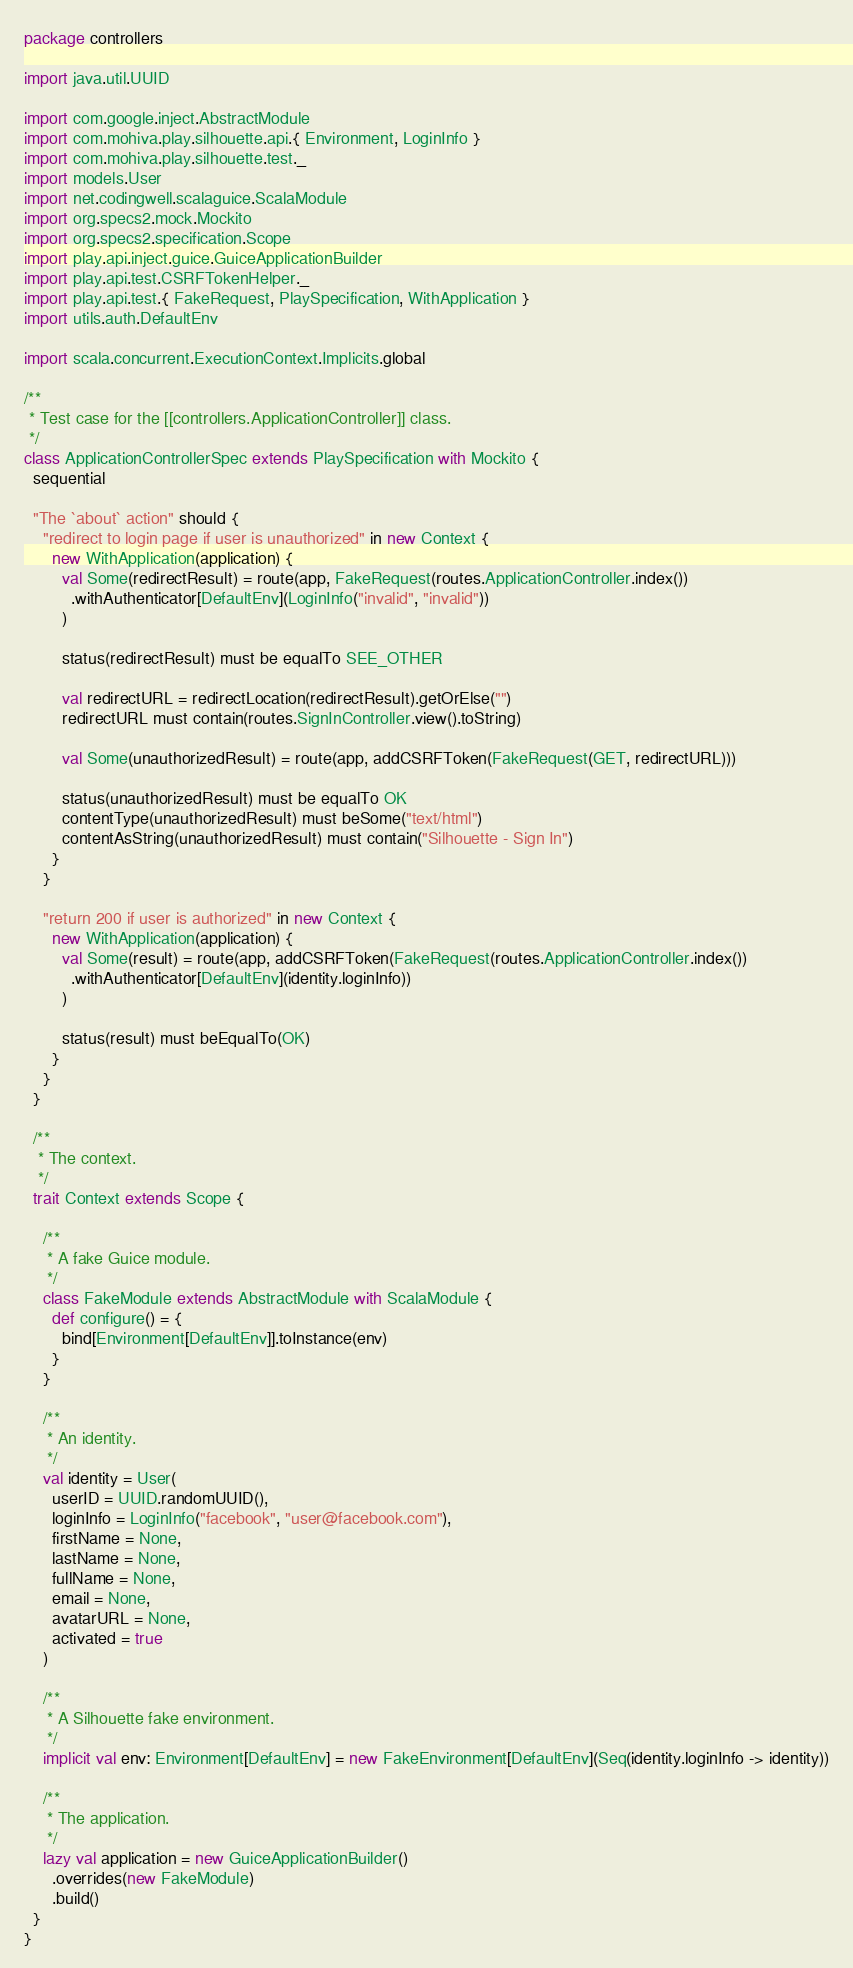<code> <loc_0><loc_0><loc_500><loc_500><_Scala_>package controllers

import java.util.UUID

import com.google.inject.AbstractModule
import com.mohiva.play.silhouette.api.{ Environment, LoginInfo }
import com.mohiva.play.silhouette.test._
import models.User
import net.codingwell.scalaguice.ScalaModule
import org.specs2.mock.Mockito
import org.specs2.specification.Scope
import play.api.inject.guice.GuiceApplicationBuilder
import play.api.test.CSRFTokenHelper._
import play.api.test.{ FakeRequest, PlaySpecification, WithApplication }
import utils.auth.DefaultEnv

import scala.concurrent.ExecutionContext.Implicits.global

/**
 * Test case for the [[controllers.ApplicationController]] class.
 */
class ApplicationControllerSpec extends PlaySpecification with Mockito {
  sequential

  "The `about` action" should {
    "redirect to login page if user is unauthorized" in new Context {
      new WithApplication(application) {
        val Some(redirectResult) = route(app, FakeRequest(routes.ApplicationController.index())
          .withAuthenticator[DefaultEnv](LoginInfo("invalid", "invalid"))
        )

        status(redirectResult) must be equalTo SEE_OTHER

        val redirectURL = redirectLocation(redirectResult).getOrElse("")
        redirectURL must contain(routes.SignInController.view().toString)

        val Some(unauthorizedResult) = route(app, addCSRFToken(FakeRequest(GET, redirectURL)))

        status(unauthorizedResult) must be equalTo OK
        contentType(unauthorizedResult) must beSome("text/html")
        contentAsString(unauthorizedResult) must contain("Silhouette - Sign In")
      }
    }

    "return 200 if user is authorized" in new Context {
      new WithApplication(application) {
        val Some(result) = route(app, addCSRFToken(FakeRequest(routes.ApplicationController.index())
          .withAuthenticator[DefaultEnv](identity.loginInfo))
        )

        status(result) must beEqualTo(OK)
      }
    }
  }

  /**
   * The context.
   */
  trait Context extends Scope {

    /**
     * A fake Guice module.
     */
    class FakeModule extends AbstractModule with ScalaModule {
      def configure() = {
        bind[Environment[DefaultEnv]].toInstance(env)
      }
    }

    /**
     * An identity.
     */
    val identity = User(
      userID = UUID.randomUUID(),
      loginInfo = LoginInfo("facebook", "user@facebook.com"),
      firstName = None,
      lastName = None,
      fullName = None,
      email = None,
      avatarURL = None,
      activated = true
    )

    /**
     * A Silhouette fake environment.
     */
    implicit val env: Environment[DefaultEnv] = new FakeEnvironment[DefaultEnv](Seq(identity.loginInfo -> identity))

    /**
     * The application.
     */
    lazy val application = new GuiceApplicationBuilder()
      .overrides(new FakeModule)
      .build()
  }
}
</code> 